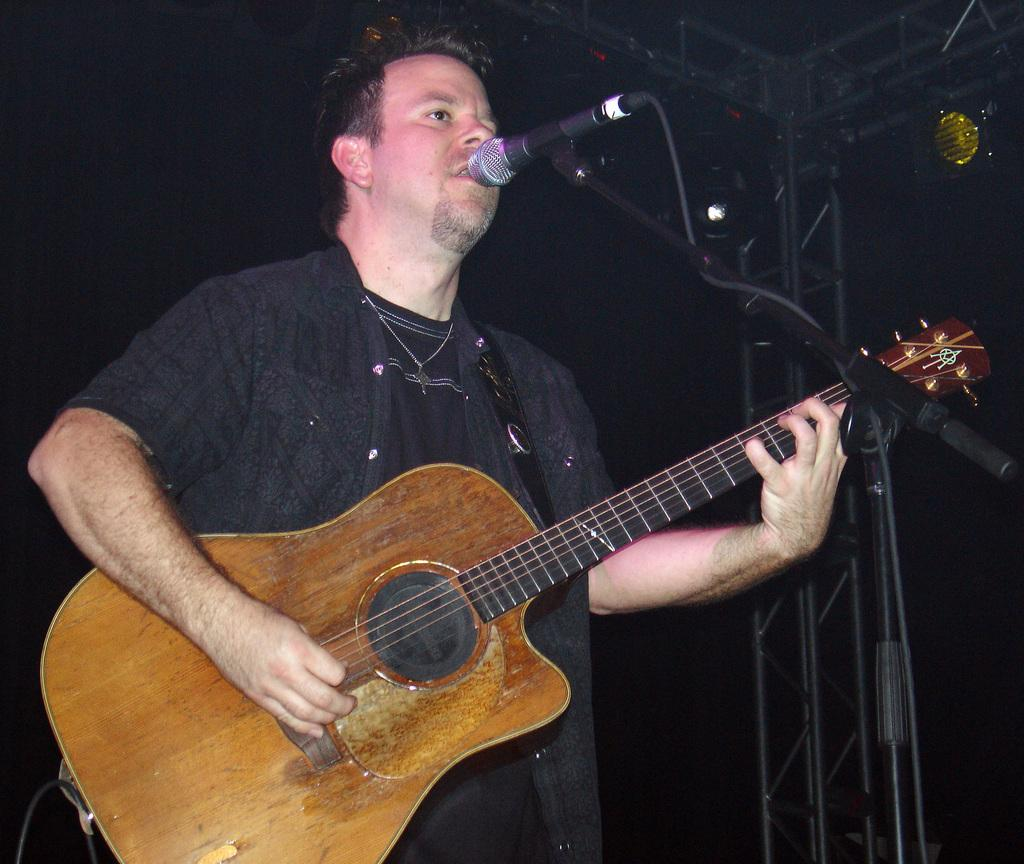What is the main subject of the image? There is a person in the center of the image. What activity is the person engaged in? The person's mouth is open, suggesting they are singing, and they are playing a guitar. What object is in front of the person? There is a microphone in front of the person. How many railway tracks can be seen behind the person in the image? There are no railway tracks visible in the image. What number is written on the person's shirt in the image? The person's shirt does not have any visible numbers in the image. 